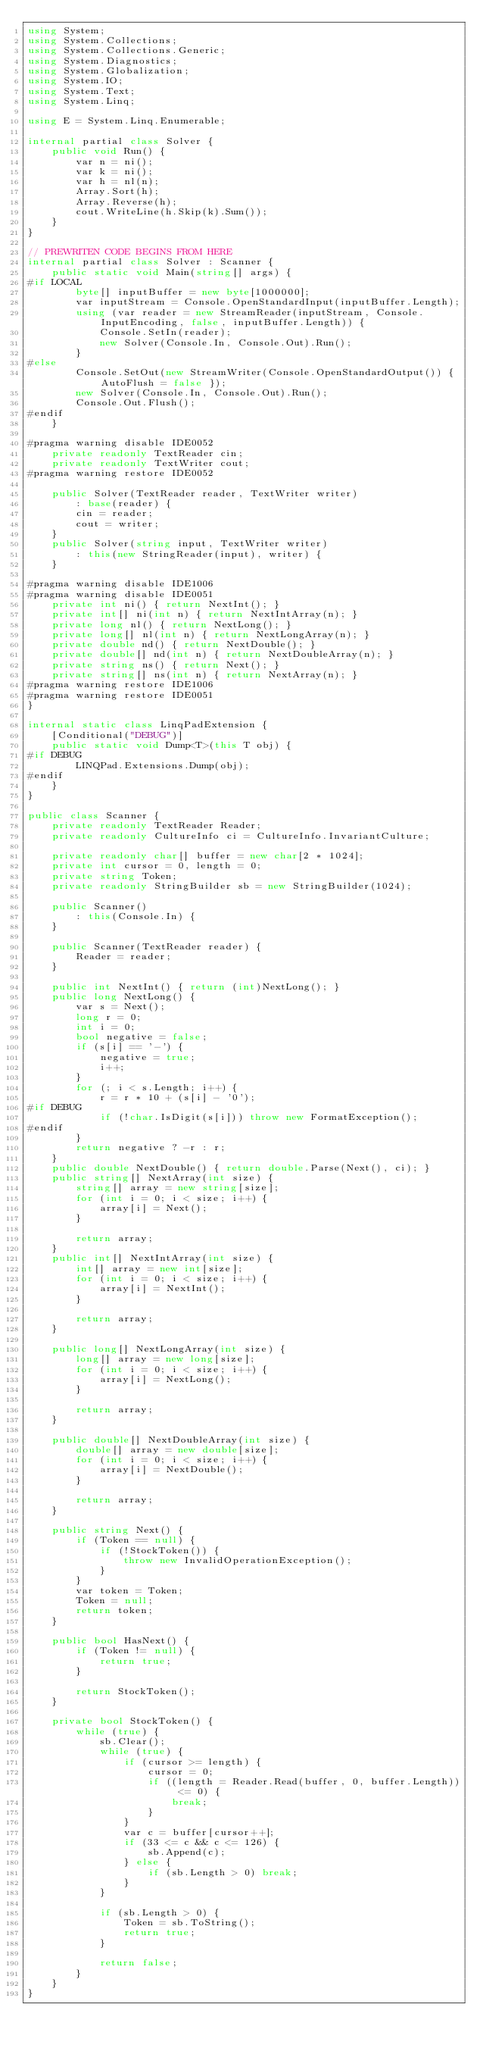<code> <loc_0><loc_0><loc_500><loc_500><_C#_>using System;
using System.Collections;
using System.Collections.Generic;
using System.Diagnostics;
using System.Globalization;
using System.IO;
using System.Text;
using System.Linq;

using E = System.Linq.Enumerable;

internal partial class Solver {
    public void Run() {
        var n = ni();
        var k = ni();
        var h = nl(n);
        Array.Sort(h);
        Array.Reverse(h);
        cout.WriteLine(h.Skip(k).Sum());
    }
}

// PREWRITEN CODE BEGINS FROM HERE
internal partial class Solver : Scanner {
    public static void Main(string[] args) {
#if LOCAL
        byte[] inputBuffer = new byte[1000000];
        var inputStream = Console.OpenStandardInput(inputBuffer.Length);
        using (var reader = new StreamReader(inputStream, Console.InputEncoding, false, inputBuffer.Length)) {
            Console.SetIn(reader);
            new Solver(Console.In, Console.Out).Run();
        }
#else
        Console.SetOut(new StreamWriter(Console.OpenStandardOutput()) { AutoFlush = false });
        new Solver(Console.In, Console.Out).Run();
        Console.Out.Flush();
#endif
    }

#pragma warning disable IDE0052
    private readonly TextReader cin;
    private readonly TextWriter cout;
#pragma warning restore IDE0052

    public Solver(TextReader reader, TextWriter writer)
        : base(reader) {
        cin = reader;
        cout = writer;
    }
    public Solver(string input, TextWriter writer)
        : this(new StringReader(input), writer) {
    }

#pragma warning disable IDE1006
#pragma warning disable IDE0051
    private int ni() { return NextInt(); }
    private int[] ni(int n) { return NextIntArray(n); }
    private long nl() { return NextLong(); }
    private long[] nl(int n) { return NextLongArray(n); }
    private double nd() { return NextDouble(); }
    private double[] nd(int n) { return NextDoubleArray(n); }
    private string ns() { return Next(); }
    private string[] ns(int n) { return NextArray(n); }
#pragma warning restore IDE1006
#pragma warning restore IDE0051
}

internal static class LinqPadExtension {
    [Conditional("DEBUG")]
    public static void Dump<T>(this T obj) {
#if DEBUG
        LINQPad.Extensions.Dump(obj);
#endif
    }
}

public class Scanner {
    private readonly TextReader Reader;
    private readonly CultureInfo ci = CultureInfo.InvariantCulture;

    private readonly char[] buffer = new char[2 * 1024];
    private int cursor = 0, length = 0;
    private string Token;
    private readonly StringBuilder sb = new StringBuilder(1024);

    public Scanner()
        : this(Console.In) {
    }

    public Scanner(TextReader reader) {
        Reader = reader;
    }

    public int NextInt() { return (int)NextLong(); }
    public long NextLong() {
        var s = Next();
        long r = 0;
        int i = 0;
        bool negative = false;
        if (s[i] == '-') {
            negative = true;
            i++;
        }
        for (; i < s.Length; i++) {
            r = r * 10 + (s[i] - '0');
#if DEBUG
            if (!char.IsDigit(s[i])) throw new FormatException();
#endif
        }
        return negative ? -r : r;
    }
    public double NextDouble() { return double.Parse(Next(), ci); }
    public string[] NextArray(int size) {
        string[] array = new string[size];
        for (int i = 0; i < size; i++) {
            array[i] = Next();
        }

        return array;
    }
    public int[] NextIntArray(int size) {
        int[] array = new int[size];
        for (int i = 0; i < size; i++) {
            array[i] = NextInt();
        }

        return array;
    }

    public long[] NextLongArray(int size) {
        long[] array = new long[size];
        for (int i = 0; i < size; i++) {
            array[i] = NextLong();
        }

        return array;
    }

    public double[] NextDoubleArray(int size) {
        double[] array = new double[size];
        for (int i = 0; i < size; i++) {
            array[i] = NextDouble();
        }

        return array;
    }

    public string Next() {
        if (Token == null) {
            if (!StockToken()) {
                throw new InvalidOperationException();
            }
        }
        var token = Token;
        Token = null;
        return token;
    }

    public bool HasNext() {
        if (Token != null) {
            return true;
        }

        return StockToken();
    }

    private bool StockToken() {
        while (true) {
            sb.Clear();
            while (true) {
                if (cursor >= length) {
                    cursor = 0;
                    if ((length = Reader.Read(buffer, 0, buffer.Length)) <= 0) {
                        break;
                    }
                }
                var c = buffer[cursor++];
                if (33 <= c && c <= 126) {
                    sb.Append(c);
                } else {
                    if (sb.Length > 0) break;
                }
            }

            if (sb.Length > 0) {
                Token = sb.ToString();
                return true;
            }

            return false;
        }
    }
}</code> 